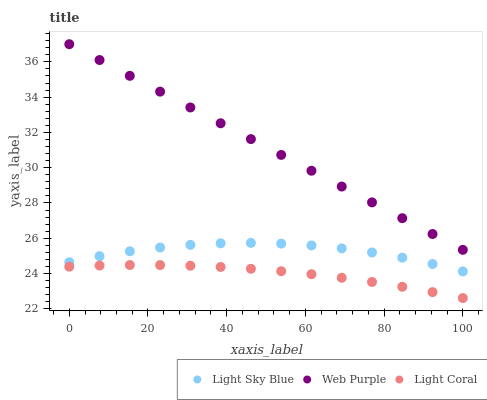Does Light Coral have the minimum area under the curve?
Answer yes or no. Yes. Does Web Purple have the maximum area under the curve?
Answer yes or no. Yes. Does Light Sky Blue have the minimum area under the curve?
Answer yes or no. No. Does Light Sky Blue have the maximum area under the curve?
Answer yes or no. No. Is Web Purple the smoothest?
Answer yes or no. Yes. Is Light Sky Blue the roughest?
Answer yes or no. Yes. Is Light Sky Blue the smoothest?
Answer yes or no. No. Is Web Purple the roughest?
Answer yes or no. No. Does Light Coral have the lowest value?
Answer yes or no. Yes. Does Light Sky Blue have the lowest value?
Answer yes or no. No. Does Web Purple have the highest value?
Answer yes or no. Yes. Does Light Sky Blue have the highest value?
Answer yes or no. No. Is Light Coral less than Web Purple?
Answer yes or no. Yes. Is Web Purple greater than Light Sky Blue?
Answer yes or no. Yes. Does Light Coral intersect Web Purple?
Answer yes or no. No. 